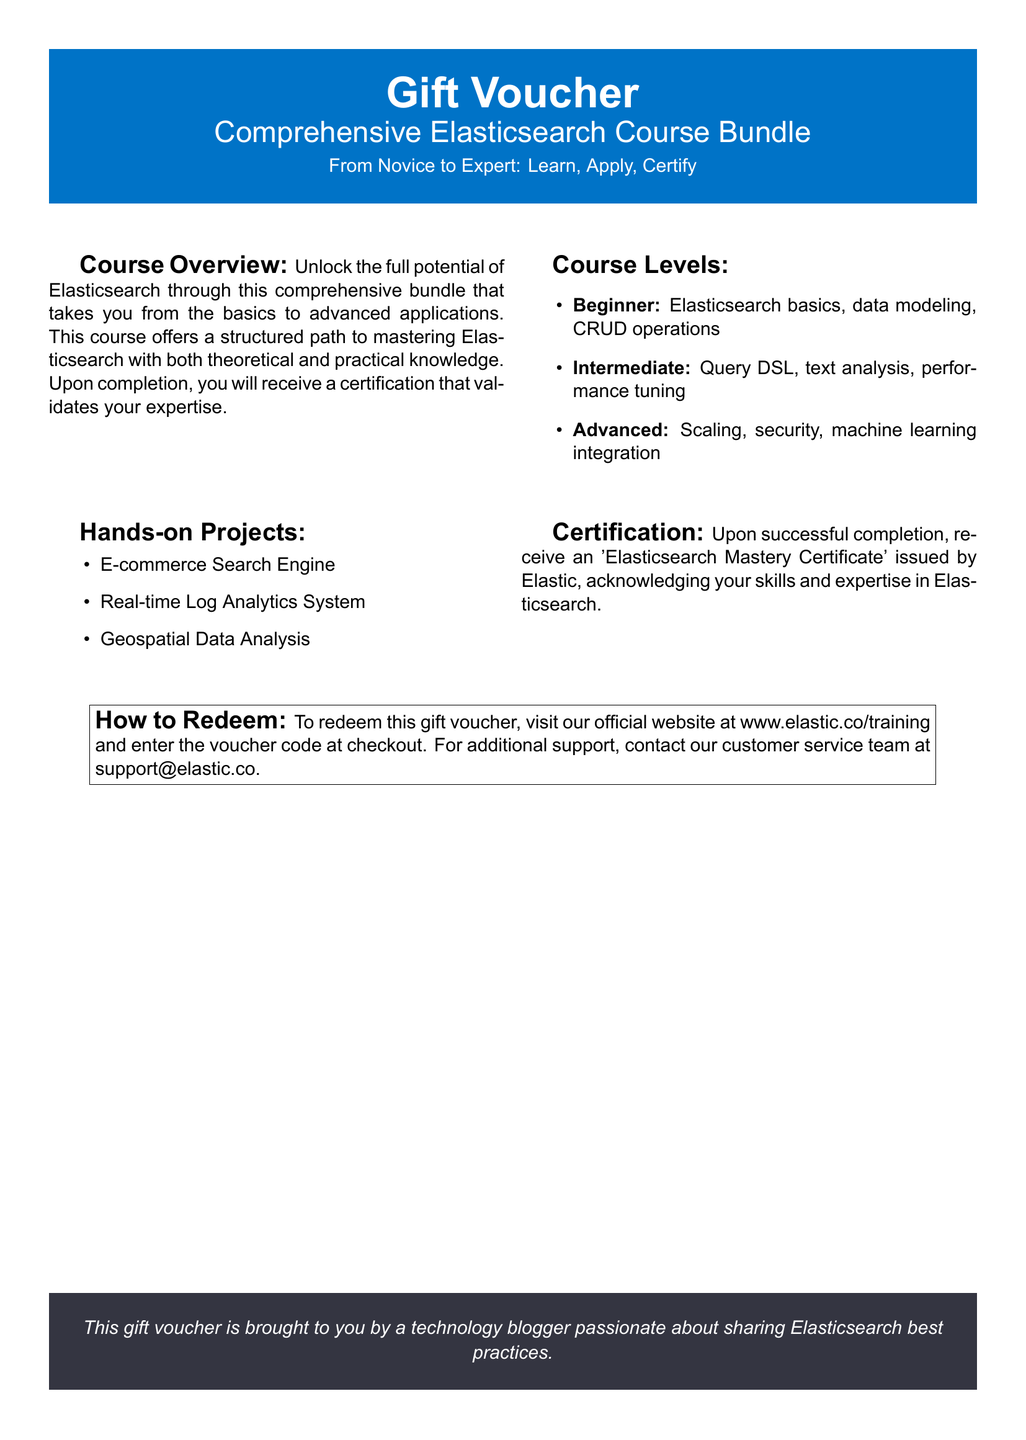What is included in the course bundle? The course bundle includes a comprehensive Elasticsearch course from basics to advanced applications, hands-on projects, and certification.
Answer: Comprehensive Elasticsearch Course Bundle What types of projects are featured in the hands-on section? The document lists specific projects that are part of the hands-on section, including an e-commerce search engine, real-time log analytics system, and geospatial data analysis.
Answer: E-commerce Search Engine, Real-time Log Analytics System, Geospatial Data Analysis What certificate is issued upon course completion? The document mentions a specific certification awarded after completion of the course.
Answer: Elasticsearch Mastery Certificate How many course levels are there? The document specifies the different levels offered in the course, which are beginner, intermediate, and advanced.
Answer: Three What should you do to redeem the gift voucher? The document instructs the steps needed to redeem the voucher, which involves visiting a specific website and entering a code.
Answer: Visit www.elastic.co/training and enter the voucher code at checkout Who issued the gift voucher? The document states the entity responsible for providing the gift voucher.
Answer: A technology blogger What is the main purpose of the course? The document outlines the goal of the course, which is to master Elasticsearch with theoretical and practical knowledge.
Answer: Mastering Elasticsearch What is the email for customer support? The document provides contact information for customer service that includes a specific email address.
Answer: support@elastic.co 